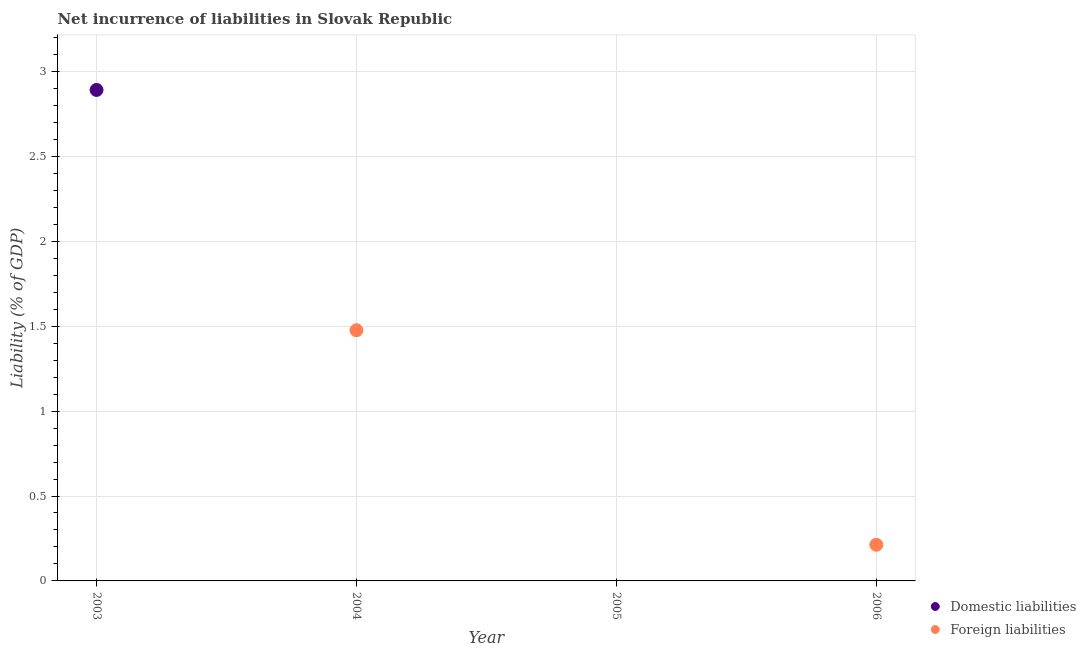Is the number of dotlines equal to the number of legend labels?
Offer a very short reply. No. What is the incurrence of foreign liabilities in 2004?
Keep it short and to the point. 1.48. Across all years, what is the maximum incurrence of domestic liabilities?
Offer a very short reply. 2.89. Across all years, what is the minimum incurrence of domestic liabilities?
Offer a very short reply. 0. What is the total incurrence of foreign liabilities in the graph?
Give a very brief answer. 1.69. What is the difference between the incurrence of domestic liabilities in 2003 and the incurrence of foreign liabilities in 2005?
Ensure brevity in your answer.  2.89. What is the average incurrence of domestic liabilities per year?
Ensure brevity in your answer.  0.72. What is the ratio of the incurrence of foreign liabilities in 2004 to that in 2006?
Keep it short and to the point. 6.93. Is the incurrence of foreign liabilities in 2004 less than that in 2006?
Offer a terse response. No. What is the difference between the highest and the lowest incurrence of foreign liabilities?
Give a very brief answer. 1.48. Is the incurrence of foreign liabilities strictly less than the incurrence of domestic liabilities over the years?
Your answer should be very brief. No. How many dotlines are there?
Your response must be concise. 2. Are the values on the major ticks of Y-axis written in scientific E-notation?
Offer a terse response. No. How many legend labels are there?
Ensure brevity in your answer.  2. What is the title of the graph?
Make the answer very short. Net incurrence of liabilities in Slovak Republic. What is the label or title of the Y-axis?
Make the answer very short. Liability (% of GDP). What is the Liability (% of GDP) in Domestic liabilities in 2003?
Make the answer very short. 2.89. What is the Liability (% of GDP) in Foreign liabilities in 2003?
Ensure brevity in your answer.  0. What is the Liability (% of GDP) in Foreign liabilities in 2004?
Give a very brief answer. 1.48. What is the Liability (% of GDP) in Foreign liabilities in 2005?
Keep it short and to the point. 0. What is the Liability (% of GDP) of Foreign liabilities in 2006?
Provide a succinct answer. 0.21. Across all years, what is the maximum Liability (% of GDP) of Domestic liabilities?
Your answer should be compact. 2.89. Across all years, what is the maximum Liability (% of GDP) of Foreign liabilities?
Keep it short and to the point. 1.48. Across all years, what is the minimum Liability (% of GDP) of Domestic liabilities?
Keep it short and to the point. 0. What is the total Liability (% of GDP) in Domestic liabilities in the graph?
Your answer should be compact. 2.89. What is the total Liability (% of GDP) of Foreign liabilities in the graph?
Your response must be concise. 1.69. What is the difference between the Liability (% of GDP) of Foreign liabilities in 2004 and that in 2006?
Provide a short and direct response. 1.26. What is the difference between the Liability (% of GDP) in Domestic liabilities in 2003 and the Liability (% of GDP) in Foreign liabilities in 2004?
Offer a terse response. 1.42. What is the difference between the Liability (% of GDP) in Domestic liabilities in 2003 and the Liability (% of GDP) in Foreign liabilities in 2006?
Keep it short and to the point. 2.68. What is the average Liability (% of GDP) of Domestic liabilities per year?
Your answer should be compact. 0.72. What is the average Liability (% of GDP) of Foreign liabilities per year?
Your answer should be compact. 0.42. What is the ratio of the Liability (% of GDP) in Foreign liabilities in 2004 to that in 2006?
Offer a terse response. 6.93. What is the difference between the highest and the lowest Liability (% of GDP) of Domestic liabilities?
Provide a succinct answer. 2.89. What is the difference between the highest and the lowest Liability (% of GDP) of Foreign liabilities?
Offer a very short reply. 1.48. 